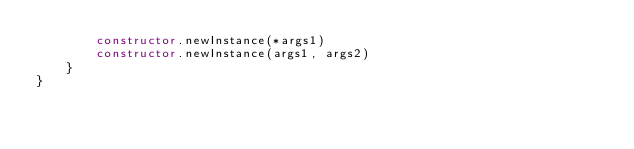Convert code to text. <code><loc_0><loc_0><loc_500><loc_500><_Kotlin_>        constructor.newInstance(*args1)
        constructor.newInstance(args1, args2)
    }
}</code> 